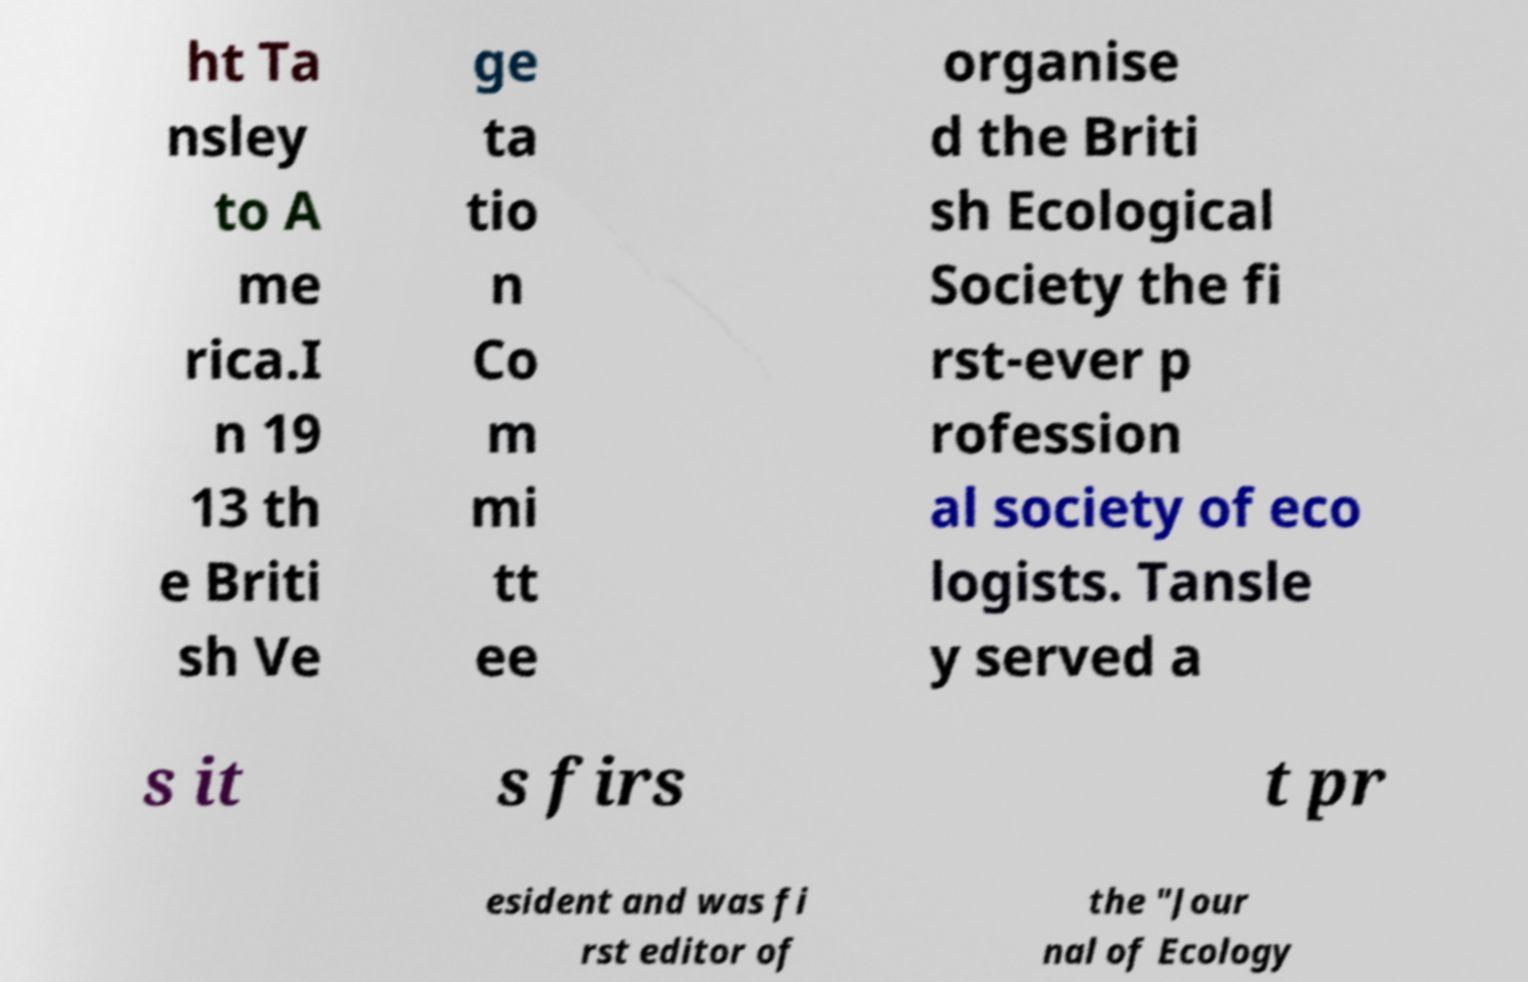There's text embedded in this image that I need extracted. Can you transcribe it verbatim? ht Ta nsley to A me rica.I n 19 13 th e Briti sh Ve ge ta tio n Co m mi tt ee organise d the Briti sh Ecological Society the fi rst-ever p rofession al society of eco logists. Tansle y served a s it s firs t pr esident and was fi rst editor of the "Jour nal of Ecology 